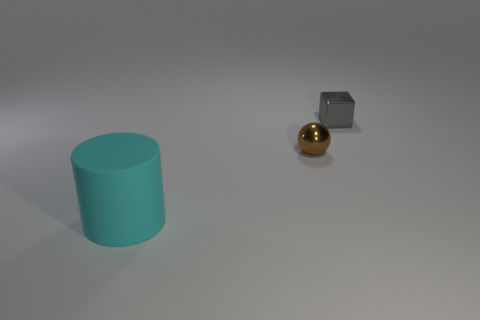There is a metallic object on the right side of the small object in front of the shiny object that is right of the tiny brown metal ball; what size is it?
Your answer should be compact. Small. What number of objects are either tiny things left of the tiny metallic cube or small objects behind the brown metal ball?
Offer a very short reply. 2. There is a tiny metallic thing that is behind the small object left of the gray metal object; what shape is it?
Your response must be concise. Cube. Is there anything else that is the same color as the big cylinder?
Your answer should be very brief. No. Is there any other thing that has the same size as the cylinder?
Your answer should be very brief. No. What number of things are big brown objects or tiny balls?
Your answer should be compact. 1. Is there a brown ball that has the same size as the cube?
Your answer should be compact. Yes. What is the shape of the brown thing?
Provide a short and direct response. Sphere. Are there more tiny metal things that are on the left side of the tiny brown metal object than large cyan rubber things that are behind the big cylinder?
Offer a very short reply. No. There is a brown thing that is the same size as the metal block; what is its shape?
Your response must be concise. Sphere. 